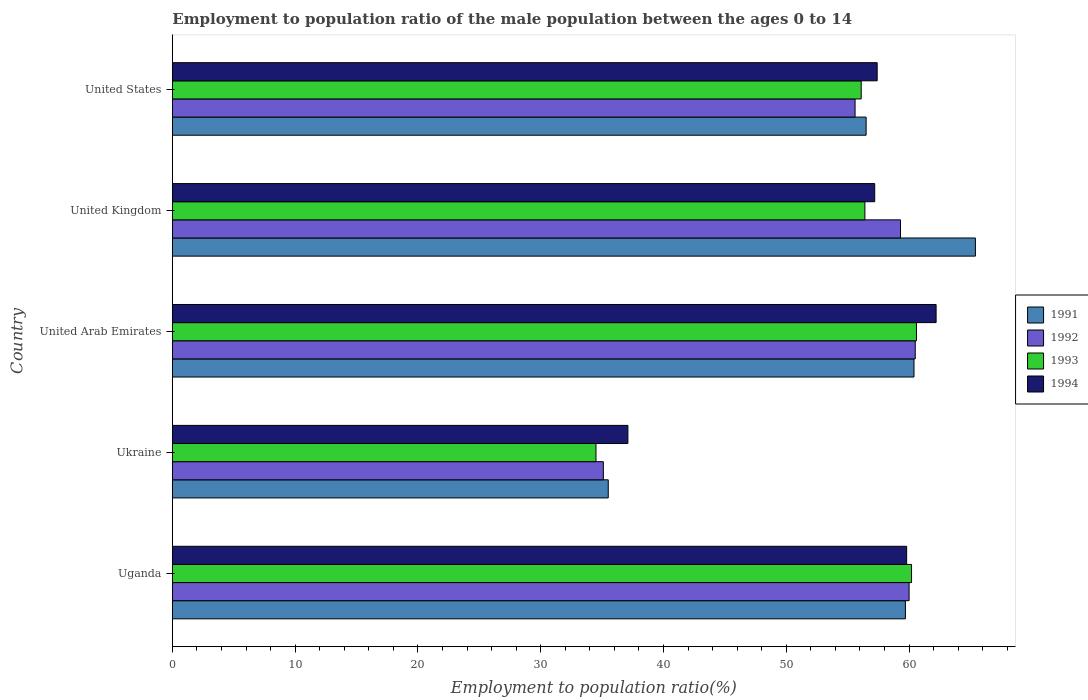How many different coloured bars are there?
Make the answer very short. 4. How many groups of bars are there?
Offer a very short reply. 5. Are the number of bars on each tick of the Y-axis equal?
Your answer should be very brief. Yes. How many bars are there on the 4th tick from the bottom?
Offer a very short reply. 4. In how many cases, is the number of bars for a given country not equal to the number of legend labels?
Your response must be concise. 0. What is the employment to population ratio in 1992 in United Kingdom?
Your response must be concise. 59.3. Across all countries, what is the maximum employment to population ratio in 1994?
Provide a succinct answer. 62.2. Across all countries, what is the minimum employment to population ratio in 1991?
Provide a succinct answer. 35.5. In which country was the employment to population ratio in 1993 maximum?
Offer a terse response. United Arab Emirates. In which country was the employment to population ratio in 1992 minimum?
Ensure brevity in your answer.  Ukraine. What is the total employment to population ratio in 1994 in the graph?
Your response must be concise. 273.7. What is the difference between the employment to population ratio in 1994 in United Kingdom and that in United States?
Your answer should be compact. -0.2. What is the difference between the employment to population ratio in 1992 in United States and the employment to population ratio in 1993 in United Kingdom?
Keep it short and to the point. -0.8. What is the average employment to population ratio in 1993 per country?
Make the answer very short. 53.56. What is the difference between the employment to population ratio in 1991 and employment to population ratio in 1994 in United Arab Emirates?
Make the answer very short. -1.8. What is the ratio of the employment to population ratio in 1992 in United Kingdom to that in United States?
Provide a succinct answer. 1.07. Is the difference between the employment to population ratio in 1991 in United Arab Emirates and United Kingdom greater than the difference between the employment to population ratio in 1994 in United Arab Emirates and United Kingdom?
Provide a succinct answer. No. What is the difference between the highest and the second highest employment to population ratio in 1993?
Make the answer very short. 0.4. What is the difference between the highest and the lowest employment to population ratio in 1991?
Your answer should be compact. 29.9. In how many countries, is the employment to population ratio in 1994 greater than the average employment to population ratio in 1994 taken over all countries?
Your answer should be very brief. 4. Is it the case that in every country, the sum of the employment to population ratio in 1993 and employment to population ratio in 1992 is greater than the sum of employment to population ratio in 1991 and employment to population ratio in 1994?
Your response must be concise. No. What does the 4th bar from the top in Ukraine represents?
Your response must be concise. 1991. What does the 1st bar from the bottom in United Kingdom represents?
Your response must be concise. 1991. Is it the case that in every country, the sum of the employment to population ratio in 1991 and employment to population ratio in 1993 is greater than the employment to population ratio in 1992?
Keep it short and to the point. Yes. Are the values on the major ticks of X-axis written in scientific E-notation?
Make the answer very short. No. Where does the legend appear in the graph?
Make the answer very short. Center right. How many legend labels are there?
Offer a terse response. 4. What is the title of the graph?
Your answer should be very brief. Employment to population ratio of the male population between the ages 0 to 14. Does "2014" appear as one of the legend labels in the graph?
Offer a very short reply. No. What is the Employment to population ratio(%) of 1991 in Uganda?
Provide a short and direct response. 59.7. What is the Employment to population ratio(%) of 1992 in Uganda?
Your answer should be very brief. 60. What is the Employment to population ratio(%) of 1993 in Uganda?
Your answer should be compact. 60.2. What is the Employment to population ratio(%) in 1994 in Uganda?
Provide a succinct answer. 59.8. What is the Employment to population ratio(%) of 1991 in Ukraine?
Your answer should be compact. 35.5. What is the Employment to population ratio(%) of 1992 in Ukraine?
Your answer should be very brief. 35.1. What is the Employment to population ratio(%) in 1993 in Ukraine?
Give a very brief answer. 34.5. What is the Employment to population ratio(%) of 1994 in Ukraine?
Your answer should be compact. 37.1. What is the Employment to population ratio(%) in 1991 in United Arab Emirates?
Offer a very short reply. 60.4. What is the Employment to population ratio(%) in 1992 in United Arab Emirates?
Offer a terse response. 60.5. What is the Employment to population ratio(%) of 1993 in United Arab Emirates?
Offer a very short reply. 60.6. What is the Employment to population ratio(%) of 1994 in United Arab Emirates?
Keep it short and to the point. 62.2. What is the Employment to population ratio(%) in 1991 in United Kingdom?
Keep it short and to the point. 65.4. What is the Employment to population ratio(%) of 1992 in United Kingdom?
Make the answer very short. 59.3. What is the Employment to population ratio(%) in 1993 in United Kingdom?
Your response must be concise. 56.4. What is the Employment to population ratio(%) of 1994 in United Kingdom?
Give a very brief answer. 57.2. What is the Employment to population ratio(%) in 1991 in United States?
Your answer should be compact. 56.5. What is the Employment to population ratio(%) of 1992 in United States?
Provide a succinct answer. 55.6. What is the Employment to population ratio(%) in 1993 in United States?
Give a very brief answer. 56.1. What is the Employment to population ratio(%) of 1994 in United States?
Make the answer very short. 57.4. Across all countries, what is the maximum Employment to population ratio(%) of 1991?
Provide a short and direct response. 65.4. Across all countries, what is the maximum Employment to population ratio(%) of 1992?
Give a very brief answer. 60.5. Across all countries, what is the maximum Employment to population ratio(%) of 1993?
Offer a terse response. 60.6. Across all countries, what is the maximum Employment to population ratio(%) of 1994?
Give a very brief answer. 62.2. Across all countries, what is the minimum Employment to population ratio(%) in 1991?
Your answer should be compact. 35.5. Across all countries, what is the minimum Employment to population ratio(%) of 1992?
Provide a succinct answer. 35.1. Across all countries, what is the minimum Employment to population ratio(%) in 1993?
Your response must be concise. 34.5. Across all countries, what is the minimum Employment to population ratio(%) in 1994?
Provide a short and direct response. 37.1. What is the total Employment to population ratio(%) of 1991 in the graph?
Provide a succinct answer. 277.5. What is the total Employment to population ratio(%) in 1992 in the graph?
Provide a succinct answer. 270.5. What is the total Employment to population ratio(%) of 1993 in the graph?
Offer a very short reply. 267.8. What is the total Employment to population ratio(%) in 1994 in the graph?
Ensure brevity in your answer.  273.7. What is the difference between the Employment to population ratio(%) of 1991 in Uganda and that in Ukraine?
Ensure brevity in your answer.  24.2. What is the difference between the Employment to population ratio(%) of 1992 in Uganda and that in Ukraine?
Keep it short and to the point. 24.9. What is the difference between the Employment to population ratio(%) in 1993 in Uganda and that in Ukraine?
Offer a very short reply. 25.7. What is the difference between the Employment to population ratio(%) of 1994 in Uganda and that in Ukraine?
Your answer should be compact. 22.7. What is the difference between the Employment to population ratio(%) of 1992 in Uganda and that in United Arab Emirates?
Keep it short and to the point. -0.5. What is the difference between the Employment to population ratio(%) in 1993 in Uganda and that in United Arab Emirates?
Your answer should be compact. -0.4. What is the difference between the Employment to population ratio(%) of 1991 in Uganda and that in United Kingdom?
Offer a terse response. -5.7. What is the difference between the Employment to population ratio(%) of 1993 in Uganda and that in United Kingdom?
Offer a very short reply. 3.8. What is the difference between the Employment to population ratio(%) of 1991 in Uganda and that in United States?
Keep it short and to the point. 3.2. What is the difference between the Employment to population ratio(%) of 1992 in Uganda and that in United States?
Provide a short and direct response. 4.4. What is the difference between the Employment to population ratio(%) of 1993 in Uganda and that in United States?
Provide a short and direct response. 4.1. What is the difference between the Employment to population ratio(%) of 1994 in Uganda and that in United States?
Keep it short and to the point. 2.4. What is the difference between the Employment to population ratio(%) in 1991 in Ukraine and that in United Arab Emirates?
Keep it short and to the point. -24.9. What is the difference between the Employment to population ratio(%) of 1992 in Ukraine and that in United Arab Emirates?
Make the answer very short. -25.4. What is the difference between the Employment to population ratio(%) of 1993 in Ukraine and that in United Arab Emirates?
Ensure brevity in your answer.  -26.1. What is the difference between the Employment to population ratio(%) in 1994 in Ukraine and that in United Arab Emirates?
Give a very brief answer. -25.1. What is the difference between the Employment to population ratio(%) in 1991 in Ukraine and that in United Kingdom?
Offer a terse response. -29.9. What is the difference between the Employment to population ratio(%) in 1992 in Ukraine and that in United Kingdom?
Provide a succinct answer. -24.2. What is the difference between the Employment to population ratio(%) of 1993 in Ukraine and that in United Kingdom?
Your response must be concise. -21.9. What is the difference between the Employment to population ratio(%) of 1994 in Ukraine and that in United Kingdom?
Your answer should be compact. -20.1. What is the difference between the Employment to population ratio(%) in 1991 in Ukraine and that in United States?
Your answer should be compact. -21. What is the difference between the Employment to population ratio(%) of 1992 in Ukraine and that in United States?
Make the answer very short. -20.5. What is the difference between the Employment to population ratio(%) in 1993 in Ukraine and that in United States?
Ensure brevity in your answer.  -21.6. What is the difference between the Employment to population ratio(%) of 1994 in Ukraine and that in United States?
Your answer should be compact. -20.3. What is the difference between the Employment to population ratio(%) of 1992 in United Arab Emirates and that in United Kingdom?
Your answer should be compact. 1.2. What is the difference between the Employment to population ratio(%) of 1993 in United Arab Emirates and that in United Kingdom?
Keep it short and to the point. 4.2. What is the difference between the Employment to population ratio(%) in 1991 in United Arab Emirates and that in United States?
Give a very brief answer. 3.9. What is the difference between the Employment to population ratio(%) of 1992 in United Kingdom and that in United States?
Offer a terse response. 3.7. What is the difference between the Employment to population ratio(%) of 1994 in United Kingdom and that in United States?
Give a very brief answer. -0.2. What is the difference between the Employment to population ratio(%) in 1991 in Uganda and the Employment to population ratio(%) in 1992 in Ukraine?
Offer a very short reply. 24.6. What is the difference between the Employment to population ratio(%) of 1991 in Uganda and the Employment to population ratio(%) of 1993 in Ukraine?
Provide a short and direct response. 25.2. What is the difference between the Employment to population ratio(%) of 1991 in Uganda and the Employment to population ratio(%) of 1994 in Ukraine?
Keep it short and to the point. 22.6. What is the difference between the Employment to population ratio(%) in 1992 in Uganda and the Employment to population ratio(%) in 1994 in Ukraine?
Make the answer very short. 22.9. What is the difference between the Employment to population ratio(%) of 1993 in Uganda and the Employment to population ratio(%) of 1994 in Ukraine?
Ensure brevity in your answer.  23.1. What is the difference between the Employment to population ratio(%) of 1991 in Uganda and the Employment to population ratio(%) of 1992 in United Arab Emirates?
Provide a short and direct response. -0.8. What is the difference between the Employment to population ratio(%) in 1991 in Uganda and the Employment to population ratio(%) in 1993 in United Arab Emirates?
Offer a very short reply. -0.9. What is the difference between the Employment to population ratio(%) in 1991 in Uganda and the Employment to population ratio(%) in 1994 in United Arab Emirates?
Keep it short and to the point. -2.5. What is the difference between the Employment to population ratio(%) in 1992 in Uganda and the Employment to population ratio(%) in 1993 in United Arab Emirates?
Ensure brevity in your answer.  -0.6. What is the difference between the Employment to population ratio(%) of 1992 in Uganda and the Employment to population ratio(%) of 1994 in United Arab Emirates?
Your answer should be very brief. -2.2. What is the difference between the Employment to population ratio(%) of 1991 in Uganda and the Employment to population ratio(%) of 1994 in United Kingdom?
Offer a terse response. 2.5. What is the difference between the Employment to population ratio(%) in 1992 in Uganda and the Employment to population ratio(%) in 1993 in United Kingdom?
Your response must be concise. 3.6. What is the difference between the Employment to population ratio(%) in 1992 in Uganda and the Employment to population ratio(%) in 1994 in United Kingdom?
Provide a succinct answer. 2.8. What is the difference between the Employment to population ratio(%) in 1991 in Uganda and the Employment to population ratio(%) in 1992 in United States?
Your response must be concise. 4.1. What is the difference between the Employment to population ratio(%) of 1991 in Uganda and the Employment to population ratio(%) of 1994 in United States?
Your answer should be very brief. 2.3. What is the difference between the Employment to population ratio(%) in 1991 in Ukraine and the Employment to population ratio(%) in 1993 in United Arab Emirates?
Offer a very short reply. -25.1. What is the difference between the Employment to population ratio(%) of 1991 in Ukraine and the Employment to population ratio(%) of 1994 in United Arab Emirates?
Offer a very short reply. -26.7. What is the difference between the Employment to population ratio(%) in 1992 in Ukraine and the Employment to population ratio(%) in 1993 in United Arab Emirates?
Provide a succinct answer. -25.5. What is the difference between the Employment to population ratio(%) in 1992 in Ukraine and the Employment to population ratio(%) in 1994 in United Arab Emirates?
Ensure brevity in your answer.  -27.1. What is the difference between the Employment to population ratio(%) in 1993 in Ukraine and the Employment to population ratio(%) in 1994 in United Arab Emirates?
Your response must be concise. -27.7. What is the difference between the Employment to population ratio(%) in 1991 in Ukraine and the Employment to population ratio(%) in 1992 in United Kingdom?
Your answer should be very brief. -23.8. What is the difference between the Employment to population ratio(%) of 1991 in Ukraine and the Employment to population ratio(%) of 1993 in United Kingdom?
Make the answer very short. -20.9. What is the difference between the Employment to population ratio(%) of 1991 in Ukraine and the Employment to population ratio(%) of 1994 in United Kingdom?
Your answer should be compact. -21.7. What is the difference between the Employment to population ratio(%) in 1992 in Ukraine and the Employment to population ratio(%) in 1993 in United Kingdom?
Your response must be concise. -21.3. What is the difference between the Employment to population ratio(%) of 1992 in Ukraine and the Employment to population ratio(%) of 1994 in United Kingdom?
Ensure brevity in your answer.  -22.1. What is the difference between the Employment to population ratio(%) of 1993 in Ukraine and the Employment to population ratio(%) of 1994 in United Kingdom?
Provide a succinct answer. -22.7. What is the difference between the Employment to population ratio(%) of 1991 in Ukraine and the Employment to population ratio(%) of 1992 in United States?
Ensure brevity in your answer.  -20.1. What is the difference between the Employment to population ratio(%) of 1991 in Ukraine and the Employment to population ratio(%) of 1993 in United States?
Give a very brief answer. -20.6. What is the difference between the Employment to population ratio(%) of 1991 in Ukraine and the Employment to population ratio(%) of 1994 in United States?
Your answer should be very brief. -21.9. What is the difference between the Employment to population ratio(%) of 1992 in Ukraine and the Employment to population ratio(%) of 1993 in United States?
Offer a terse response. -21. What is the difference between the Employment to population ratio(%) in 1992 in Ukraine and the Employment to population ratio(%) in 1994 in United States?
Your answer should be very brief. -22.3. What is the difference between the Employment to population ratio(%) of 1993 in Ukraine and the Employment to population ratio(%) of 1994 in United States?
Your response must be concise. -22.9. What is the difference between the Employment to population ratio(%) in 1992 in United Arab Emirates and the Employment to population ratio(%) in 1993 in United Kingdom?
Make the answer very short. 4.1. What is the difference between the Employment to population ratio(%) in 1993 in United Arab Emirates and the Employment to population ratio(%) in 1994 in United Kingdom?
Your answer should be compact. 3.4. What is the difference between the Employment to population ratio(%) of 1991 in United Arab Emirates and the Employment to population ratio(%) of 1992 in United States?
Keep it short and to the point. 4.8. What is the difference between the Employment to population ratio(%) of 1991 in United Arab Emirates and the Employment to population ratio(%) of 1994 in United States?
Keep it short and to the point. 3. What is the difference between the Employment to population ratio(%) in 1992 in United Arab Emirates and the Employment to population ratio(%) in 1993 in United States?
Your answer should be very brief. 4.4. What is the difference between the Employment to population ratio(%) of 1992 in United Arab Emirates and the Employment to population ratio(%) of 1994 in United States?
Offer a terse response. 3.1. What is the difference between the Employment to population ratio(%) of 1991 in United Kingdom and the Employment to population ratio(%) of 1994 in United States?
Offer a terse response. 8. What is the difference between the Employment to population ratio(%) of 1993 in United Kingdom and the Employment to population ratio(%) of 1994 in United States?
Keep it short and to the point. -1. What is the average Employment to population ratio(%) of 1991 per country?
Your response must be concise. 55.5. What is the average Employment to population ratio(%) in 1992 per country?
Provide a succinct answer. 54.1. What is the average Employment to population ratio(%) of 1993 per country?
Provide a succinct answer. 53.56. What is the average Employment to population ratio(%) of 1994 per country?
Your answer should be compact. 54.74. What is the difference between the Employment to population ratio(%) of 1991 and Employment to population ratio(%) of 1992 in Uganda?
Make the answer very short. -0.3. What is the difference between the Employment to population ratio(%) in 1992 and Employment to population ratio(%) in 1994 in Uganda?
Your response must be concise. 0.2. What is the difference between the Employment to population ratio(%) of 1993 and Employment to population ratio(%) of 1994 in Uganda?
Provide a short and direct response. 0.4. What is the difference between the Employment to population ratio(%) in 1991 and Employment to population ratio(%) in 1993 in Ukraine?
Your answer should be compact. 1. What is the difference between the Employment to population ratio(%) of 1991 and Employment to population ratio(%) of 1994 in Ukraine?
Keep it short and to the point. -1.6. What is the difference between the Employment to population ratio(%) in 1992 and Employment to population ratio(%) in 1993 in Ukraine?
Provide a succinct answer. 0.6. What is the difference between the Employment to population ratio(%) in 1992 and Employment to population ratio(%) in 1994 in Ukraine?
Your response must be concise. -2. What is the difference between the Employment to population ratio(%) in 1991 and Employment to population ratio(%) in 1993 in United Arab Emirates?
Provide a succinct answer. -0.2. What is the difference between the Employment to population ratio(%) in 1991 and Employment to population ratio(%) in 1994 in United Arab Emirates?
Offer a very short reply. -1.8. What is the difference between the Employment to population ratio(%) of 1992 and Employment to population ratio(%) of 1993 in United Arab Emirates?
Provide a succinct answer. -0.1. What is the difference between the Employment to population ratio(%) of 1992 and Employment to population ratio(%) of 1994 in United Arab Emirates?
Make the answer very short. -1.7. What is the difference between the Employment to population ratio(%) in 1993 and Employment to population ratio(%) in 1994 in United Arab Emirates?
Ensure brevity in your answer.  -1.6. What is the difference between the Employment to population ratio(%) in 1991 and Employment to population ratio(%) in 1992 in United Kingdom?
Your response must be concise. 6.1. What is the difference between the Employment to population ratio(%) of 1991 and Employment to population ratio(%) of 1993 in United Kingdom?
Provide a succinct answer. 9. What is the difference between the Employment to population ratio(%) in 1991 and Employment to population ratio(%) in 1994 in United Kingdom?
Offer a terse response. 8.2. What is the difference between the Employment to population ratio(%) in 1992 and Employment to population ratio(%) in 1993 in United Kingdom?
Provide a short and direct response. 2.9. What is the difference between the Employment to population ratio(%) of 1992 and Employment to population ratio(%) of 1994 in United Kingdom?
Provide a short and direct response. 2.1. What is the difference between the Employment to population ratio(%) in 1991 and Employment to population ratio(%) in 1993 in United States?
Make the answer very short. 0.4. What is the difference between the Employment to population ratio(%) in 1991 and Employment to population ratio(%) in 1994 in United States?
Your response must be concise. -0.9. What is the difference between the Employment to population ratio(%) of 1992 and Employment to population ratio(%) of 1994 in United States?
Your answer should be very brief. -1.8. What is the ratio of the Employment to population ratio(%) of 1991 in Uganda to that in Ukraine?
Offer a very short reply. 1.68. What is the ratio of the Employment to population ratio(%) in 1992 in Uganda to that in Ukraine?
Offer a very short reply. 1.71. What is the ratio of the Employment to population ratio(%) of 1993 in Uganda to that in Ukraine?
Provide a succinct answer. 1.74. What is the ratio of the Employment to population ratio(%) of 1994 in Uganda to that in Ukraine?
Make the answer very short. 1.61. What is the ratio of the Employment to population ratio(%) of 1991 in Uganda to that in United Arab Emirates?
Make the answer very short. 0.99. What is the ratio of the Employment to population ratio(%) of 1992 in Uganda to that in United Arab Emirates?
Offer a very short reply. 0.99. What is the ratio of the Employment to population ratio(%) in 1994 in Uganda to that in United Arab Emirates?
Ensure brevity in your answer.  0.96. What is the ratio of the Employment to population ratio(%) in 1991 in Uganda to that in United Kingdom?
Offer a terse response. 0.91. What is the ratio of the Employment to population ratio(%) of 1992 in Uganda to that in United Kingdom?
Make the answer very short. 1.01. What is the ratio of the Employment to population ratio(%) of 1993 in Uganda to that in United Kingdom?
Ensure brevity in your answer.  1.07. What is the ratio of the Employment to population ratio(%) in 1994 in Uganda to that in United Kingdom?
Your answer should be compact. 1.05. What is the ratio of the Employment to population ratio(%) in 1991 in Uganda to that in United States?
Your answer should be compact. 1.06. What is the ratio of the Employment to population ratio(%) of 1992 in Uganda to that in United States?
Your response must be concise. 1.08. What is the ratio of the Employment to population ratio(%) of 1993 in Uganda to that in United States?
Your answer should be very brief. 1.07. What is the ratio of the Employment to population ratio(%) of 1994 in Uganda to that in United States?
Ensure brevity in your answer.  1.04. What is the ratio of the Employment to population ratio(%) in 1991 in Ukraine to that in United Arab Emirates?
Your response must be concise. 0.59. What is the ratio of the Employment to population ratio(%) of 1992 in Ukraine to that in United Arab Emirates?
Provide a succinct answer. 0.58. What is the ratio of the Employment to population ratio(%) in 1993 in Ukraine to that in United Arab Emirates?
Offer a terse response. 0.57. What is the ratio of the Employment to population ratio(%) of 1994 in Ukraine to that in United Arab Emirates?
Ensure brevity in your answer.  0.6. What is the ratio of the Employment to population ratio(%) of 1991 in Ukraine to that in United Kingdom?
Offer a very short reply. 0.54. What is the ratio of the Employment to population ratio(%) in 1992 in Ukraine to that in United Kingdom?
Offer a terse response. 0.59. What is the ratio of the Employment to population ratio(%) of 1993 in Ukraine to that in United Kingdom?
Your answer should be very brief. 0.61. What is the ratio of the Employment to population ratio(%) of 1994 in Ukraine to that in United Kingdom?
Offer a terse response. 0.65. What is the ratio of the Employment to population ratio(%) of 1991 in Ukraine to that in United States?
Your response must be concise. 0.63. What is the ratio of the Employment to population ratio(%) in 1992 in Ukraine to that in United States?
Keep it short and to the point. 0.63. What is the ratio of the Employment to population ratio(%) of 1993 in Ukraine to that in United States?
Provide a succinct answer. 0.61. What is the ratio of the Employment to population ratio(%) in 1994 in Ukraine to that in United States?
Give a very brief answer. 0.65. What is the ratio of the Employment to population ratio(%) in 1991 in United Arab Emirates to that in United Kingdom?
Keep it short and to the point. 0.92. What is the ratio of the Employment to population ratio(%) in 1992 in United Arab Emirates to that in United Kingdom?
Provide a short and direct response. 1.02. What is the ratio of the Employment to population ratio(%) of 1993 in United Arab Emirates to that in United Kingdom?
Keep it short and to the point. 1.07. What is the ratio of the Employment to population ratio(%) of 1994 in United Arab Emirates to that in United Kingdom?
Your answer should be very brief. 1.09. What is the ratio of the Employment to population ratio(%) of 1991 in United Arab Emirates to that in United States?
Make the answer very short. 1.07. What is the ratio of the Employment to population ratio(%) in 1992 in United Arab Emirates to that in United States?
Your response must be concise. 1.09. What is the ratio of the Employment to population ratio(%) in 1993 in United Arab Emirates to that in United States?
Your answer should be compact. 1.08. What is the ratio of the Employment to population ratio(%) of 1994 in United Arab Emirates to that in United States?
Your response must be concise. 1.08. What is the ratio of the Employment to population ratio(%) in 1991 in United Kingdom to that in United States?
Provide a succinct answer. 1.16. What is the ratio of the Employment to population ratio(%) in 1992 in United Kingdom to that in United States?
Give a very brief answer. 1.07. What is the difference between the highest and the second highest Employment to population ratio(%) in 1991?
Offer a terse response. 5. What is the difference between the highest and the lowest Employment to population ratio(%) of 1991?
Give a very brief answer. 29.9. What is the difference between the highest and the lowest Employment to population ratio(%) of 1992?
Provide a short and direct response. 25.4. What is the difference between the highest and the lowest Employment to population ratio(%) in 1993?
Make the answer very short. 26.1. What is the difference between the highest and the lowest Employment to population ratio(%) of 1994?
Offer a terse response. 25.1. 